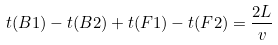Convert formula to latex. <formula><loc_0><loc_0><loc_500><loc_500>t ( B 1 ) - t ( B 2 ) + t ( F 1 ) - t ( F 2 ) = \frac { 2 L } { v }</formula> 